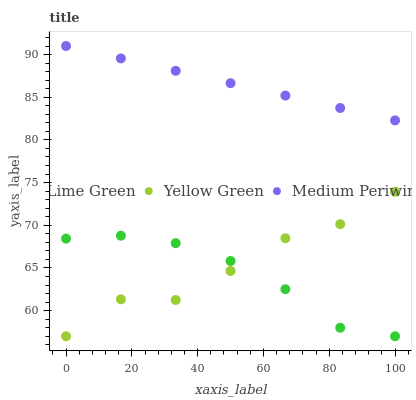Does Lime Green have the minimum area under the curve?
Answer yes or no. Yes. Does Medium Periwinkle have the maximum area under the curve?
Answer yes or no. Yes. Does Yellow Green have the minimum area under the curve?
Answer yes or no. No. Does Yellow Green have the maximum area under the curve?
Answer yes or no. No. Is Medium Periwinkle the smoothest?
Answer yes or no. Yes. Is Yellow Green the roughest?
Answer yes or no. Yes. Is Lime Green the smoothest?
Answer yes or no. No. Is Lime Green the roughest?
Answer yes or no. No. Does Lime Green have the lowest value?
Answer yes or no. Yes. Does Medium Periwinkle have the highest value?
Answer yes or no. Yes. Does Yellow Green have the highest value?
Answer yes or no. No. Is Yellow Green less than Medium Periwinkle?
Answer yes or no. Yes. Is Medium Periwinkle greater than Yellow Green?
Answer yes or no. Yes. Does Lime Green intersect Yellow Green?
Answer yes or no. Yes. Is Lime Green less than Yellow Green?
Answer yes or no. No. Is Lime Green greater than Yellow Green?
Answer yes or no. No. Does Yellow Green intersect Medium Periwinkle?
Answer yes or no. No. 